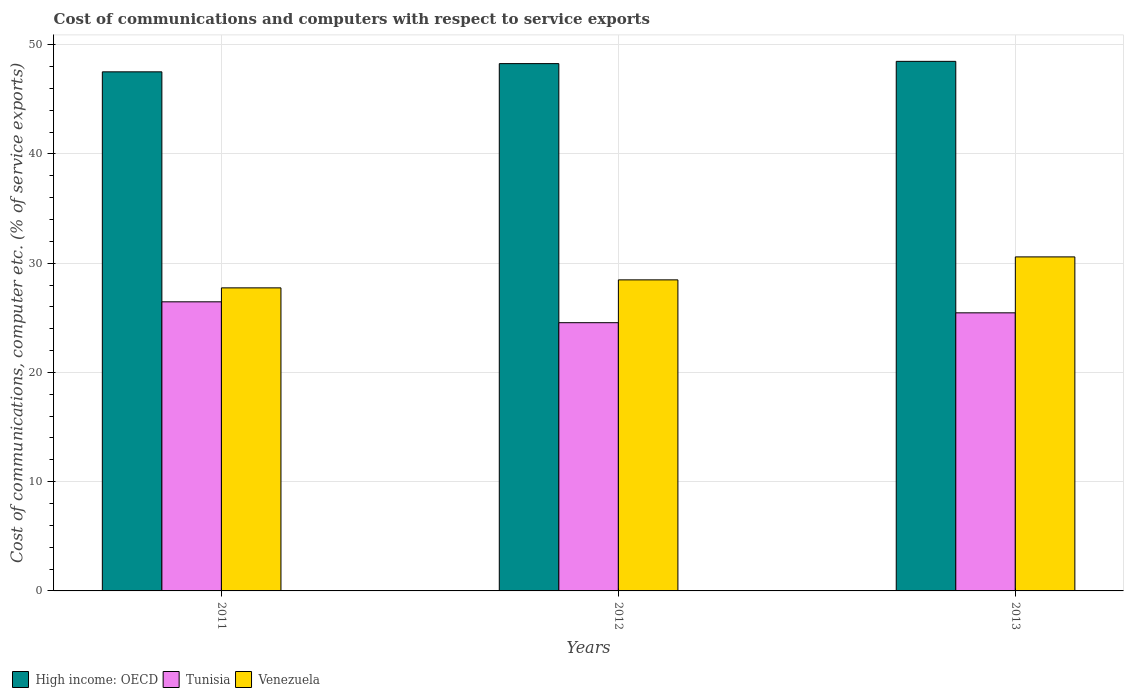How many groups of bars are there?
Your answer should be compact. 3. What is the label of the 3rd group of bars from the left?
Give a very brief answer. 2013. In how many cases, is the number of bars for a given year not equal to the number of legend labels?
Offer a very short reply. 0. What is the cost of communications and computers in High income: OECD in 2013?
Give a very brief answer. 48.48. Across all years, what is the maximum cost of communications and computers in Tunisia?
Ensure brevity in your answer.  26.46. Across all years, what is the minimum cost of communications and computers in Tunisia?
Offer a very short reply. 24.55. In which year was the cost of communications and computers in High income: OECD minimum?
Make the answer very short. 2011. What is the total cost of communications and computers in High income: OECD in the graph?
Give a very brief answer. 144.26. What is the difference between the cost of communications and computers in Venezuela in 2012 and that in 2013?
Your answer should be very brief. -2.1. What is the difference between the cost of communications and computers in High income: OECD in 2011 and the cost of communications and computers in Tunisia in 2012?
Your answer should be compact. 22.96. What is the average cost of communications and computers in High income: OECD per year?
Offer a terse response. 48.09. In the year 2011, what is the difference between the cost of communications and computers in High income: OECD and cost of communications and computers in Venezuela?
Your answer should be compact. 19.78. What is the ratio of the cost of communications and computers in Venezuela in 2011 to that in 2013?
Make the answer very short. 0.91. Is the difference between the cost of communications and computers in High income: OECD in 2011 and 2013 greater than the difference between the cost of communications and computers in Venezuela in 2011 and 2013?
Offer a very short reply. Yes. What is the difference between the highest and the second highest cost of communications and computers in High income: OECD?
Provide a succinct answer. 0.21. What is the difference between the highest and the lowest cost of communications and computers in Tunisia?
Offer a very short reply. 1.91. In how many years, is the cost of communications and computers in Tunisia greater than the average cost of communications and computers in Tunisia taken over all years?
Provide a short and direct response. 1. Is the sum of the cost of communications and computers in Venezuela in 2012 and 2013 greater than the maximum cost of communications and computers in High income: OECD across all years?
Make the answer very short. Yes. What does the 2nd bar from the left in 2012 represents?
Offer a terse response. Tunisia. What does the 3rd bar from the right in 2012 represents?
Provide a succinct answer. High income: OECD. How many bars are there?
Give a very brief answer. 9. What is the difference between two consecutive major ticks on the Y-axis?
Ensure brevity in your answer.  10. Are the values on the major ticks of Y-axis written in scientific E-notation?
Provide a succinct answer. No. Where does the legend appear in the graph?
Provide a short and direct response. Bottom left. How are the legend labels stacked?
Offer a very short reply. Horizontal. What is the title of the graph?
Provide a succinct answer. Cost of communications and computers with respect to service exports. What is the label or title of the Y-axis?
Keep it short and to the point. Cost of communications, computer etc. (% of service exports). What is the Cost of communications, computer etc. (% of service exports) in High income: OECD in 2011?
Your answer should be compact. 47.52. What is the Cost of communications, computer etc. (% of service exports) in Tunisia in 2011?
Offer a very short reply. 26.46. What is the Cost of communications, computer etc. (% of service exports) in Venezuela in 2011?
Offer a terse response. 27.74. What is the Cost of communications, computer etc. (% of service exports) in High income: OECD in 2012?
Your response must be concise. 48.27. What is the Cost of communications, computer etc. (% of service exports) in Tunisia in 2012?
Make the answer very short. 24.55. What is the Cost of communications, computer etc. (% of service exports) in Venezuela in 2012?
Your answer should be very brief. 28.47. What is the Cost of communications, computer etc. (% of service exports) of High income: OECD in 2013?
Offer a terse response. 48.48. What is the Cost of communications, computer etc. (% of service exports) in Tunisia in 2013?
Your response must be concise. 25.46. What is the Cost of communications, computer etc. (% of service exports) of Venezuela in 2013?
Provide a short and direct response. 30.58. Across all years, what is the maximum Cost of communications, computer etc. (% of service exports) of High income: OECD?
Offer a very short reply. 48.48. Across all years, what is the maximum Cost of communications, computer etc. (% of service exports) of Tunisia?
Provide a succinct answer. 26.46. Across all years, what is the maximum Cost of communications, computer etc. (% of service exports) of Venezuela?
Offer a terse response. 30.58. Across all years, what is the minimum Cost of communications, computer etc. (% of service exports) of High income: OECD?
Give a very brief answer. 47.52. Across all years, what is the minimum Cost of communications, computer etc. (% of service exports) of Tunisia?
Your answer should be compact. 24.55. Across all years, what is the minimum Cost of communications, computer etc. (% of service exports) of Venezuela?
Offer a very short reply. 27.74. What is the total Cost of communications, computer etc. (% of service exports) in High income: OECD in the graph?
Provide a short and direct response. 144.26. What is the total Cost of communications, computer etc. (% of service exports) in Tunisia in the graph?
Your answer should be compact. 76.47. What is the total Cost of communications, computer etc. (% of service exports) of Venezuela in the graph?
Provide a short and direct response. 86.79. What is the difference between the Cost of communications, computer etc. (% of service exports) of High income: OECD in 2011 and that in 2012?
Your response must be concise. -0.75. What is the difference between the Cost of communications, computer etc. (% of service exports) in Tunisia in 2011 and that in 2012?
Your answer should be compact. 1.91. What is the difference between the Cost of communications, computer etc. (% of service exports) in Venezuela in 2011 and that in 2012?
Offer a very short reply. -0.73. What is the difference between the Cost of communications, computer etc. (% of service exports) in High income: OECD in 2011 and that in 2013?
Provide a succinct answer. -0.96. What is the difference between the Cost of communications, computer etc. (% of service exports) of Tunisia in 2011 and that in 2013?
Ensure brevity in your answer.  1.01. What is the difference between the Cost of communications, computer etc. (% of service exports) of Venezuela in 2011 and that in 2013?
Offer a very short reply. -2.84. What is the difference between the Cost of communications, computer etc. (% of service exports) in High income: OECD in 2012 and that in 2013?
Keep it short and to the point. -0.21. What is the difference between the Cost of communications, computer etc. (% of service exports) in Tunisia in 2012 and that in 2013?
Provide a short and direct response. -0.9. What is the difference between the Cost of communications, computer etc. (% of service exports) in Venezuela in 2012 and that in 2013?
Your answer should be very brief. -2.1. What is the difference between the Cost of communications, computer etc. (% of service exports) in High income: OECD in 2011 and the Cost of communications, computer etc. (% of service exports) in Tunisia in 2012?
Make the answer very short. 22.96. What is the difference between the Cost of communications, computer etc. (% of service exports) of High income: OECD in 2011 and the Cost of communications, computer etc. (% of service exports) of Venezuela in 2012?
Provide a short and direct response. 19.04. What is the difference between the Cost of communications, computer etc. (% of service exports) in Tunisia in 2011 and the Cost of communications, computer etc. (% of service exports) in Venezuela in 2012?
Keep it short and to the point. -2.01. What is the difference between the Cost of communications, computer etc. (% of service exports) of High income: OECD in 2011 and the Cost of communications, computer etc. (% of service exports) of Tunisia in 2013?
Your answer should be very brief. 22.06. What is the difference between the Cost of communications, computer etc. (% of service exports) in High income: OECD in 2011 and the Cost of communications, computer etc. (% of service exports) in Venezuela in 2013?
Make the answer very short. 16.94. What is the difference between the Cost of communications, computer etc. (% of service exports) of Tunisia in 2011 and the Cost of communications, computer etc. (% of service exports) of Venezuela in 2013?
Keep it short and to the point. -4.11. What is the difference between the Cost of communications, computer etc. (% of service exports) in High income: OECD in 2012 and the Cost of communications, computer etc. (% of service exports) in Tunisia in 2013?
Offer a terse response. 22.81. What is the difference between the Cost of communications, computer etc. (% of service exports) in High income: OECD in 2012 and the Cost of communications, computer etc. (% of service exports) in Venezuela in 2013?
Your response must be concise. 17.69. What is the difference between the Cost of communications, computer etc. (% of service exports) of Tunisia in 2012 and the Cost of communications, computer etc. (% of service exports) of Venezuela in 2013?
Provide a succinct answer. -6.02. What is the average Cost of communications, computer etc. (% of service exports) of High income: OECD per year?
Your response must be concise. 48.09. What is the average Cost of communications, computer etc. (% of service exports) in Tunisia per year?
Provide a short and direct response. 25.49. What is the average Cost of communications, computer etc. (% of service exports) of Venezuela per year?
Your response must be concise. 28.93. In the year 2011, what is the difference between the Cost of communications, computer etc. (% of service exports) of High income: OECD and Cost of communications, computer etc. (% of service exports) of Tunisia?
Your answer should be compact. 21.05. In the year 2011, what is the difference between the Cost of communications, computer etc. (% of service exports) in High income: OECD and Cost of communications, computer etc. (% of service exports) in Venezuela?
Keep it short and to the point. 19.78. In the year 2011, what is the difference between the Cost of communications, computer etc. (% of service exports) in Tunisia and Cost of communications, computer etc. (% of service exports) in Venezuela?
Give a very brief answer. -1.28. In the year 2012, what is the difference between the Cost of communications, computer etc. (% of service exports) in High income: OECD and Cost of communications, computer etc. (% of service exports) in Tunisia?
Provide a short and direct response. 23.72. In the year 2012, what is the difference between the Cost of communications, computer etc. (% of service exports) in High income: OECD and Cost of communications, computer etc. (% of service exports) in Venezuela?
Your answer should be compact. 19.79. In the year 2012, what is the difference between the Cost of communications, computer etc. (% of service exports) of Tunisia and Cost of communications, computer etc. (% of service exports) of Venezuela?
Provide a short and direct response. -3.92. In the year 2013, what is the difference between the Cost of communications, computer etc. (% of service exports) of High income: OECD and Cost of communications, computer etc. (% of service exports) of Tunisia?
Keep it short and to the point. 23.02. In the year 2013, what is the difference between the Cost of communications, computer etc. (% of service exports) in High income: OECD and Cost of communications, computer etc. (% of service exports) in Venezuela?
Ensure brevity in your answer.  17.9. In the year 2013, what is the difference between the Cost of communications, computer etc. (% of service exports) in Tunisia and Cost of communications, computer etc. (% of service exports) in Venezuela?
Offer a terse response. -5.12. What is the ratio of the Cost of communications, computer etc. (% of service exports) in High income: OECD in 2011 to that in 2012?
Your response must be concise. 0.98. What is the ratio of the Cost of communications, computer etc. (% of service exports) of Tunisia in 2011 to that in 2012?
Give a very brief answer. 1.08. What is the ratio of the Cost of communications, computer etc. (% of service exports) in Venezuela in 2011 to that in 2012?
Make the answer very short. 0.97. What is the ratio of the Cost of communications, computer etc. (% of service exports) in High income: OECD in 2011 to that in 2013?
Offer a terse response. 0.98. What is the ratio of the Cost of communications, computer etc. (% of service exports) in Tunisia in 2011 to that in 2013?
Make the answer very short. 1.04. What is the ratio of the Cost of communications, computer etc. (% of service exports) of Venezuela in 2011 to that in 2013?
Your answer should be very brief. 0.91. What is the ratio of the Cost of communications, computer etc. (% of service exports) in Tunisia in 2012 to that in 2013?
Your answer should be compact. 0.96. What is the ratio of the Cost of communications, computer etc. (% of service exports) of Venezuela in 2012 to that in 2013?
Offer a very short reply. 0.93. What is the difference between the highest and the second highest Cost of communications, computer etc. (% of service exports) of High income: OECD?
Keep it short and to the point. 0.21. What is the difference between the highest and the second highest Cost of communications, computer etc. (% of service exports) of Tunisia?
Provide a short and direct response. 1.01. What is the difference between the highest and the second highest Cost of communications, computer etc. (% of service exports) of Venezuela?
Offer a very short reply. 2.1. What is the difference between the highest and the lowest Cost of communications, computer etc. (% of service exports) in High income: OECD?
Offer a terse response. 0.96. What is the difference between the highest and the lowest Cost of communications, computer etc. (% of service exports) in Tunisia?
Make the answer very short. 1.91. What is the difference between the highest and the lowest Cost of communications, computer etc. (% of service exports) in Venezuela?
Keep it short and to the point. 2.84. 